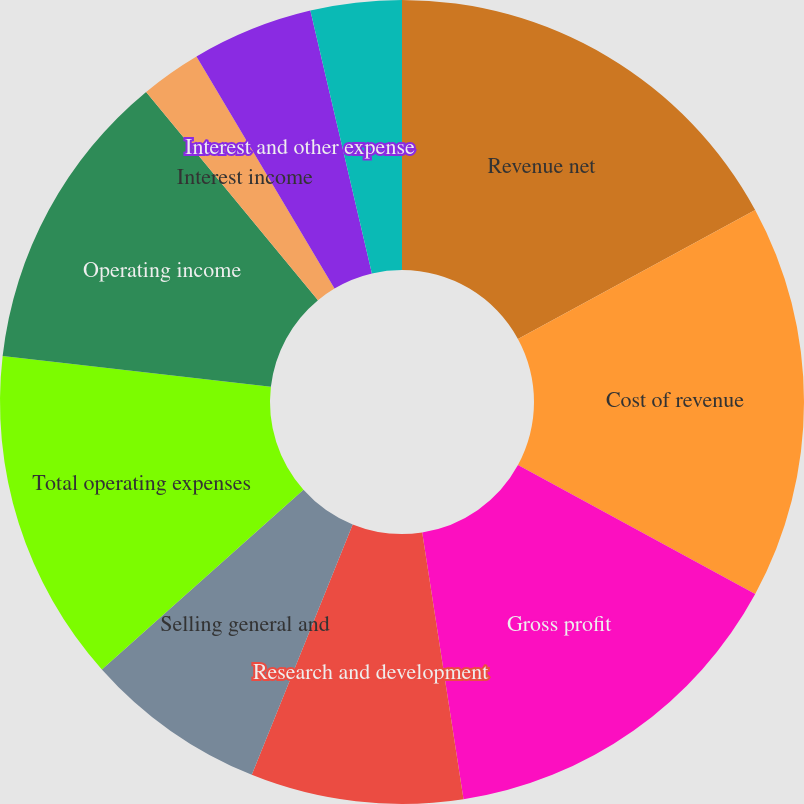Convert chart to OTSL. <chart><loc_0><loc_0><loc_500><loc_500><pie_chart><fcel>Revenue net<fcel>Cost of revenue<fcel>Gross profit<fcel>Research and development<fcel>Selling general and<fcel>Total operating expenses<fcel>Operating income<fcel>Interest income<fcel>Interest and other expense<fcel>Total other expense net<nl><fcel>17.07%<fcel>15.85%<fcel>14.63%<fcel>8.54%<fcel>7.32%<fcel>13.41%<fcel>12.19%<fcel>2.44%<fcel>4.88%<fcel>3.66%<nl></chart> 